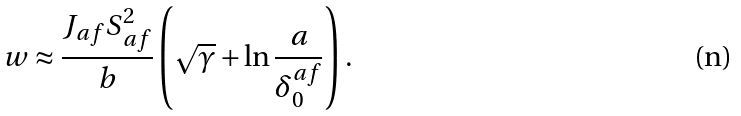Convert formula to latex. <formula><loc_0><loc_0><loc_500><loc_500>w \approx \frac { J _ { a f } S _ { a f } ^ { 2 } } { b } \left ( \sqrt { \gamma } + \ln \frac { a } { \delta _ { 0 } ^ { a f } } \right ) .</formula> 